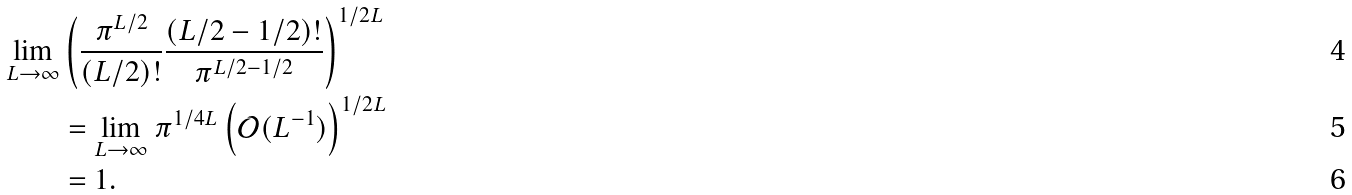Convert formula to latex. <formula><loc_0><loc_0><loc_500><loc_500>\lim _ { L \rightarrow \infty } & \left ( \frac { \pi ^ { L / 2 } } { ( L / 2 ) ! } \frac { ( L / 2 - 1 / 2 ) ! } { \pi ^ { L / 2 - 1 / 2 } } \right ) ^ { 1 / 2 L } \\ & = \lim _ { L \rightarrow \infty } \pi ^ { 1 / 4 L } \left ( \mathcal { O } ( L ^ { - 1 } ) \right ) ^ { 1 / 2 L } \\ & = 1 .</formula> 